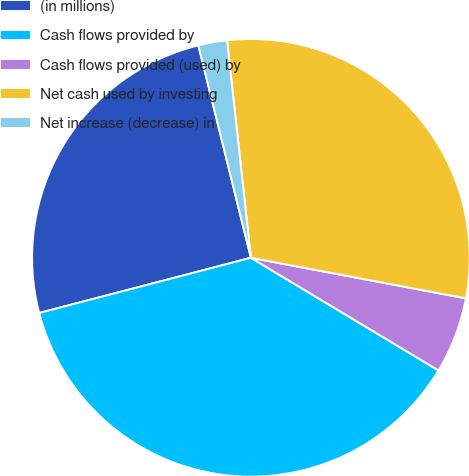Convert chart to OTSL. <chart><loc_0><loc_0><loc_500><loc_500><pie_chart><fcel>(in millions)<fcel>Cash flows provided by<fcel>Cash flows provided (used) by<fcel>Net cash used by investing<fcel>Net increase (decrease) in<nl><fcel>25.2%<fcel>37.33%<fcel>5.64%<fcel>29.71%<fcel>2.12%<nl></chart> 